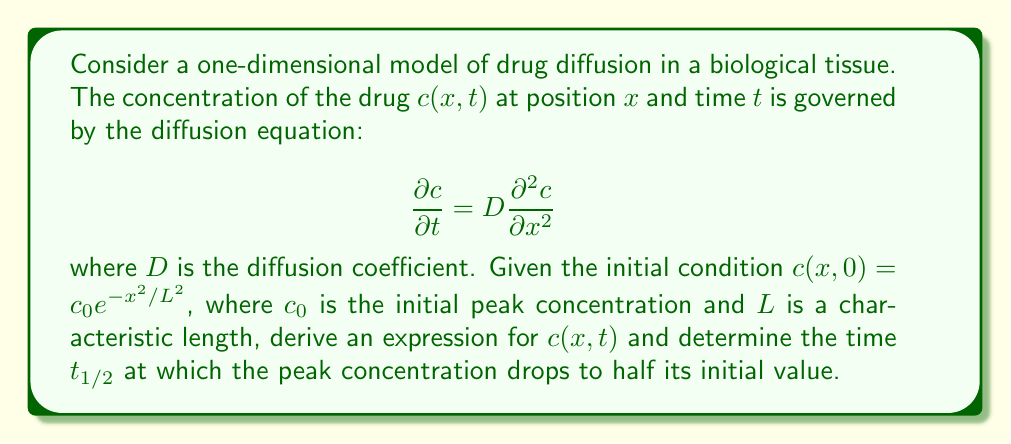Solve this math problem. To solve this problem, we'll follow these steps:

1) The general solution to the diffusion equation with the given initial condition is:

   $$c(x,t) = \frac{c_0L}{\sqrt{L^2 + 4Dt}} \exp\left(-\frac{x^2}{L^2 + 4Dt}\right)$$

2) The peak concentration occurs at $x = 0$ for all $t$. Therefore, the peak concentration as a function of time is:

   $$c(0,t) = \frac{c_0L}{\sqrt{L^2 + 4Dt}}$$

3) To find $t_{1/2}$, we set this equal to half the initial peak concentration:

   $$\frac{c_0L}{\sqrt{L^2 + 4Dt_{1/2}}} = \frac{c_0}{2}$$

4) Squaring both sides:

   $$\frac{c_0^2L^2}{L^2 + 4Dt_{1/2}} = \frac{c_0^2}{4}$$

5) Solving for $t_{1/2}$:

   $$L^2 + 4Dt_{1/2} = 4L^2$$
   $$4Dt_{1/2} = 3L^2$$
   $$t_{1/2} = \frac{3L^2}{4D}$$

This result shows that the time for the peak concentration to halve is proportional to the square of the characteristic length and inversely proportional to the diffusion coefficient.
Answer: $t_{1/2} = \frac{3L^2}{4D}$ 